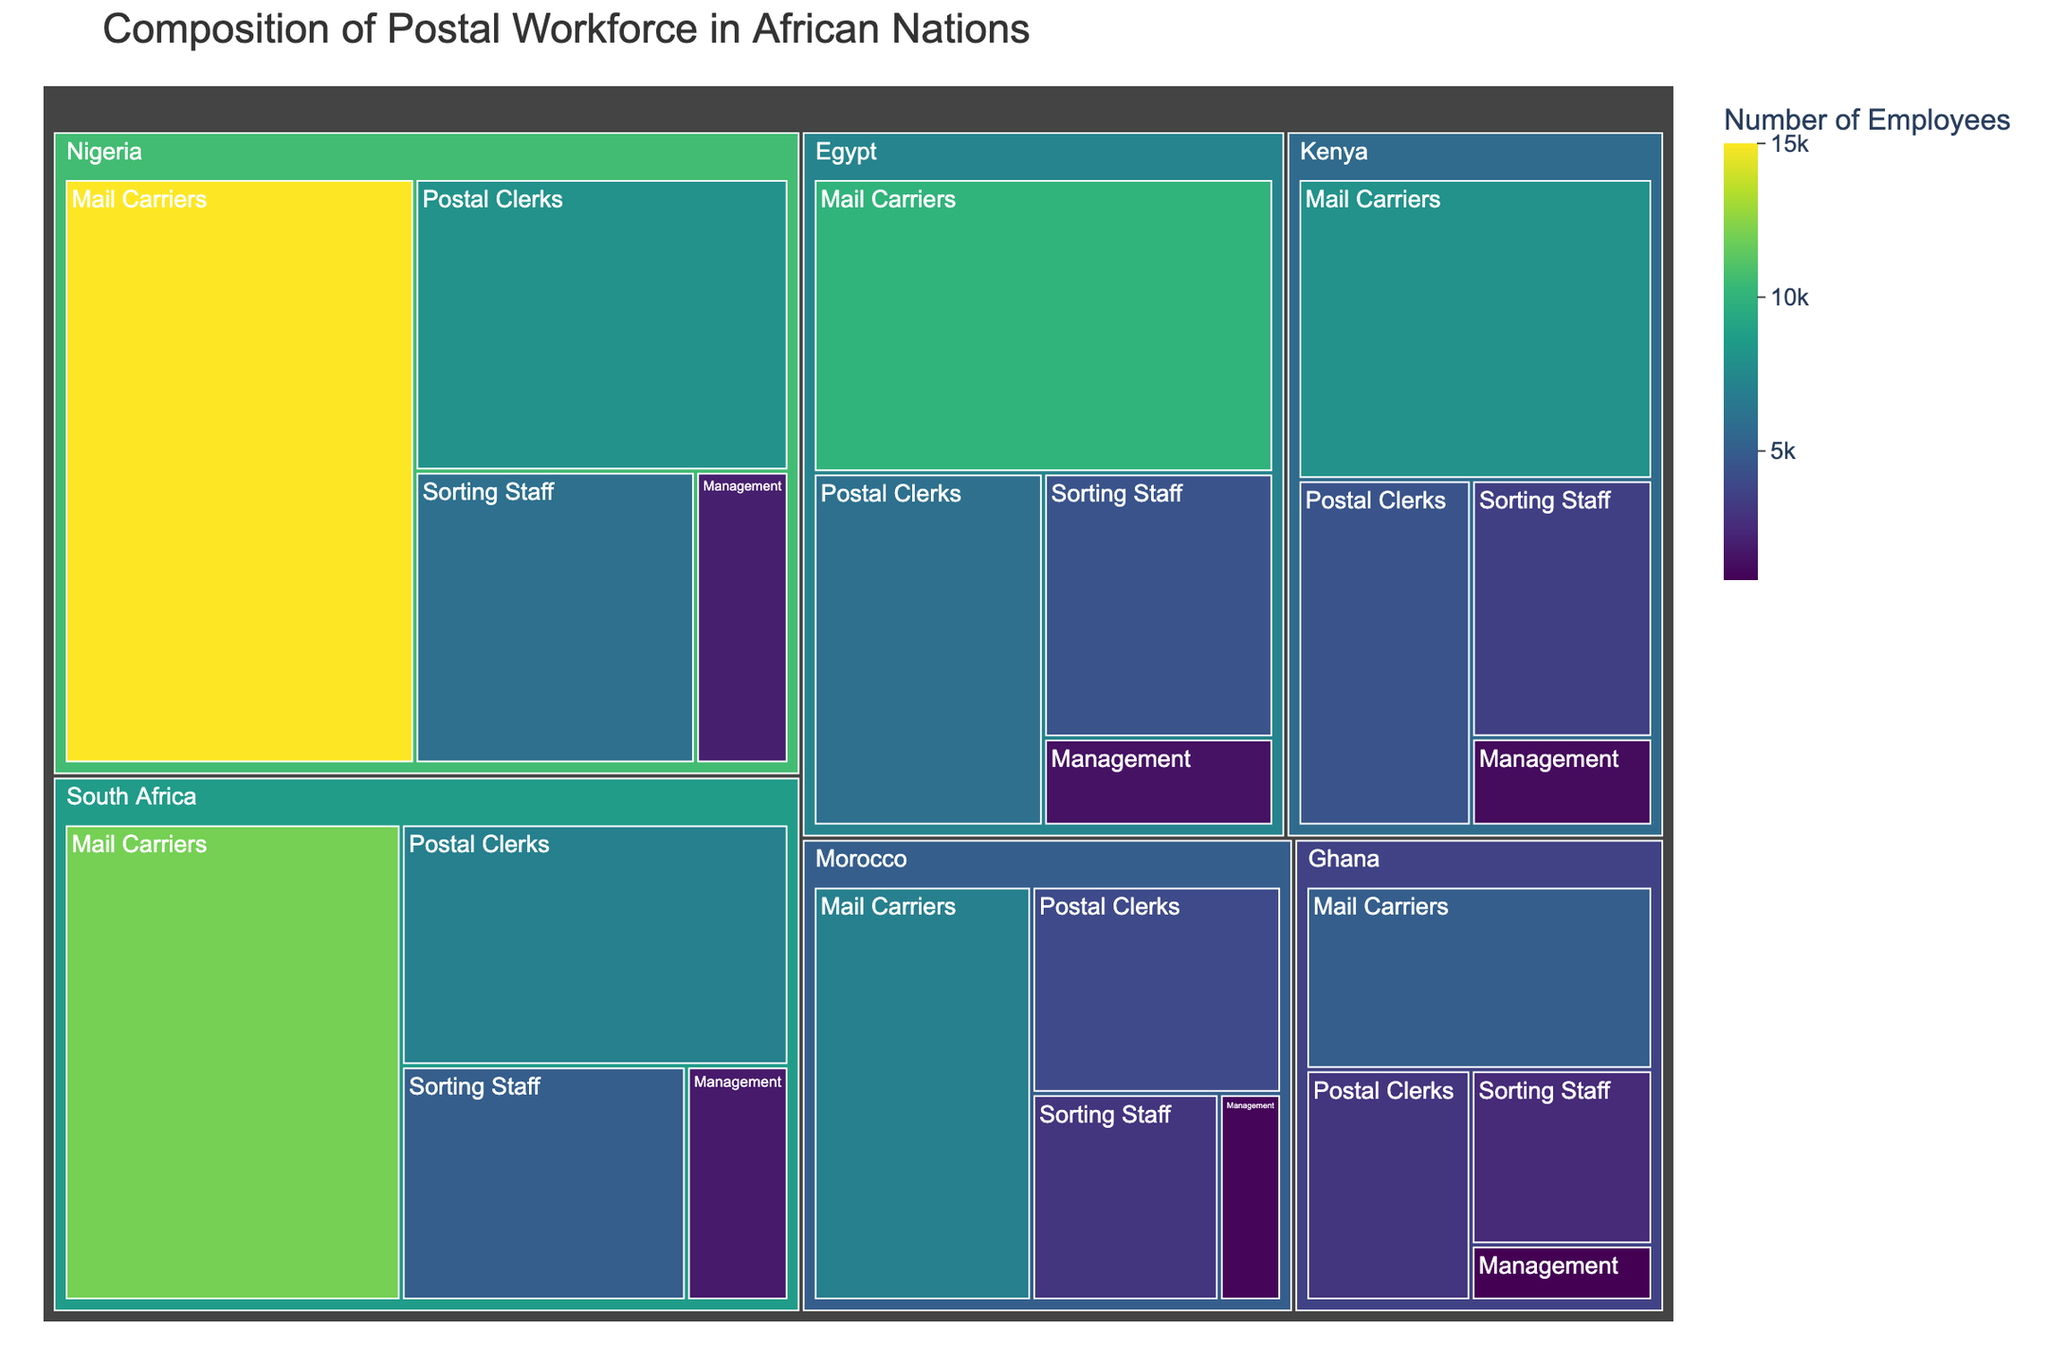what is the title of the figure? The title of a figure is usually found at the top of the plot. By looking at the plot, the title clearly states the subject of the data shown.
Answer: Composition of Postal Workforce in African Nations Which country has the highest number of Mail Carriers? Look for the Mail Carriers category within each country segment in the treemap. The size of the section and color intensity signal the quantity. Nigeria shows the largest and most intense section for Mail Carriers.
Answer: Nigeria What is the total number of Sorting Staff employees across all countries? Sum up the number of Sorting Staff employees from each country: 6000 (Nigeria) + 5000 (South Africa) + 3500 (Kenya) + 4500 (Egypt) + 2500 (Ghana) + 3000 (Morocco) = 24500.
Answer: 24500 How many more Postal Clerks does Egypt have compared to Ghana? Identify the number of Postal Clerks for each country and subtract Ghana's number from Egypt's: 6000 (Egypt) - 3000 (Ghana) = 3000.
Answer: 3000 Which country has the smallest management workforce? Look for the Management category in the treemap for each country and determine which has the smallest section. Ghana shows the smallest section for Management.
Answer: Ghana Which country has the largest postal workforce overall? Sum the total employees for all job categories for each country and identify the largest sum: Nigeria: 15000 + 8000 + 6000 + 2000 = 31000, South Africa: 25800, Kenya: 17200, Egypt: 22000, Ghana: 11300, Morocco: 15000. Nigeria has the highest total.
Answer: Nigeria What percentage of the total workforce in Kenya does the Sorting Staff constitute? Determine Kenya's total workforce and the Sorting Staff percentage: 3500 (Sorting Staff) / 17200 (Total) * 100 = approximately 20.35%.
Answer: ~20.35% Compare the number of employees in Management between Egypt and Morocco. Which has more? Examine the Management category in Egypt and Morocco, then compare: Egypt has 1500, Morocco has 1000. Therefore, Egypt has more Management employees.
Answer: Egypt What is the sum of Postal Clerks and Mail Carriers in South Africa? Add the number of Postal Clerks and Mail Carriers in South Africa: 7000 (Postal Clerks) + 12000 (Mail Carriers) = 19000.
Answer: 19000 Which African country has an equal number of Mail Carriers and Sorting Staff? Review each country's data to find Mail Carriers and Sorting Staff with the same number. No country in the data has equal numbers for these categories.
Answer: None 